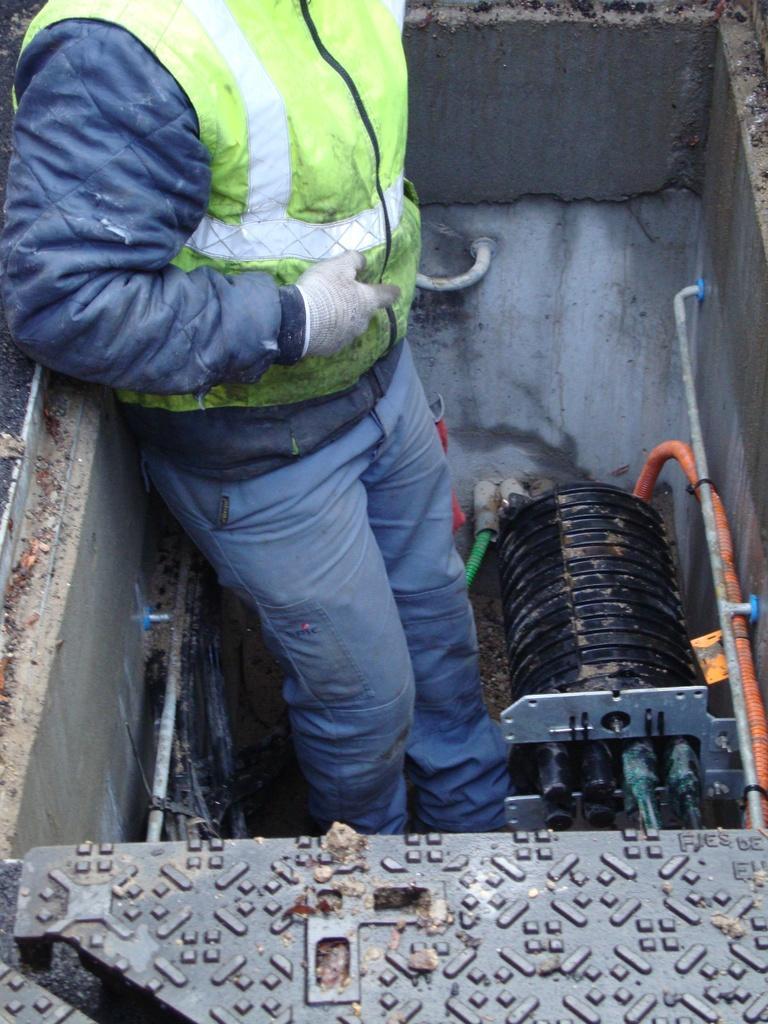Please provide a concise description of this image. In this in the center there is one person and beside him there is one machine, and at the bottom there is one board and in the background there is a wall and some pipes. 